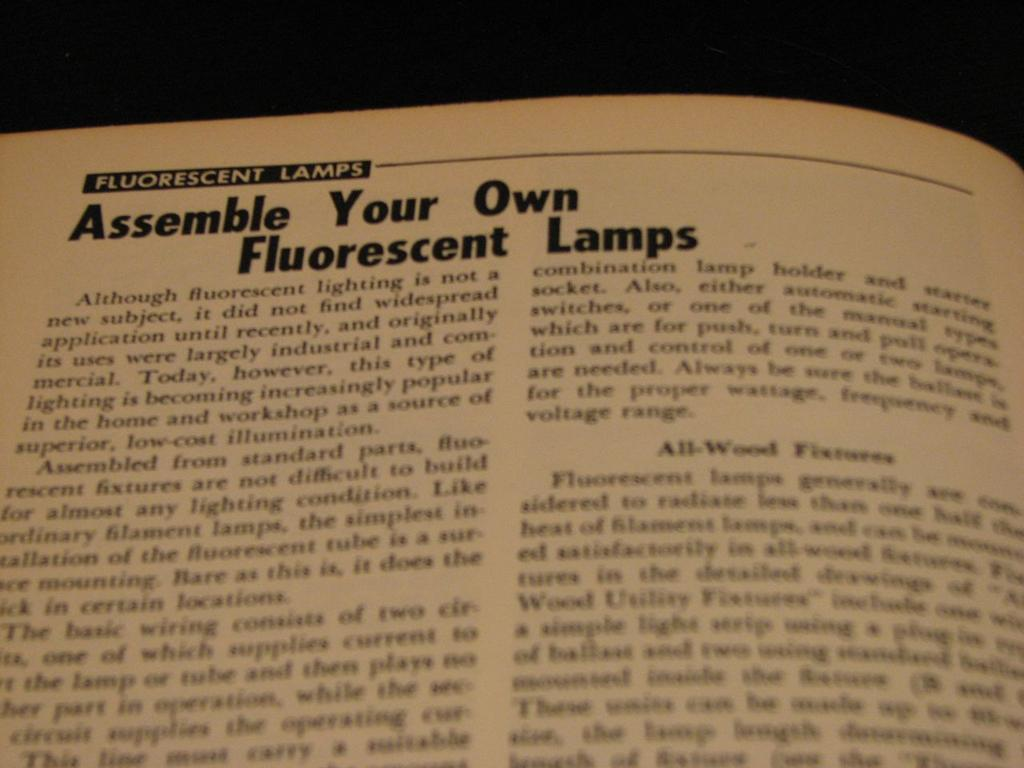Provide a one-sentence caption for the provided image. a page that says 'fluorescent lamps' at the top of it. 